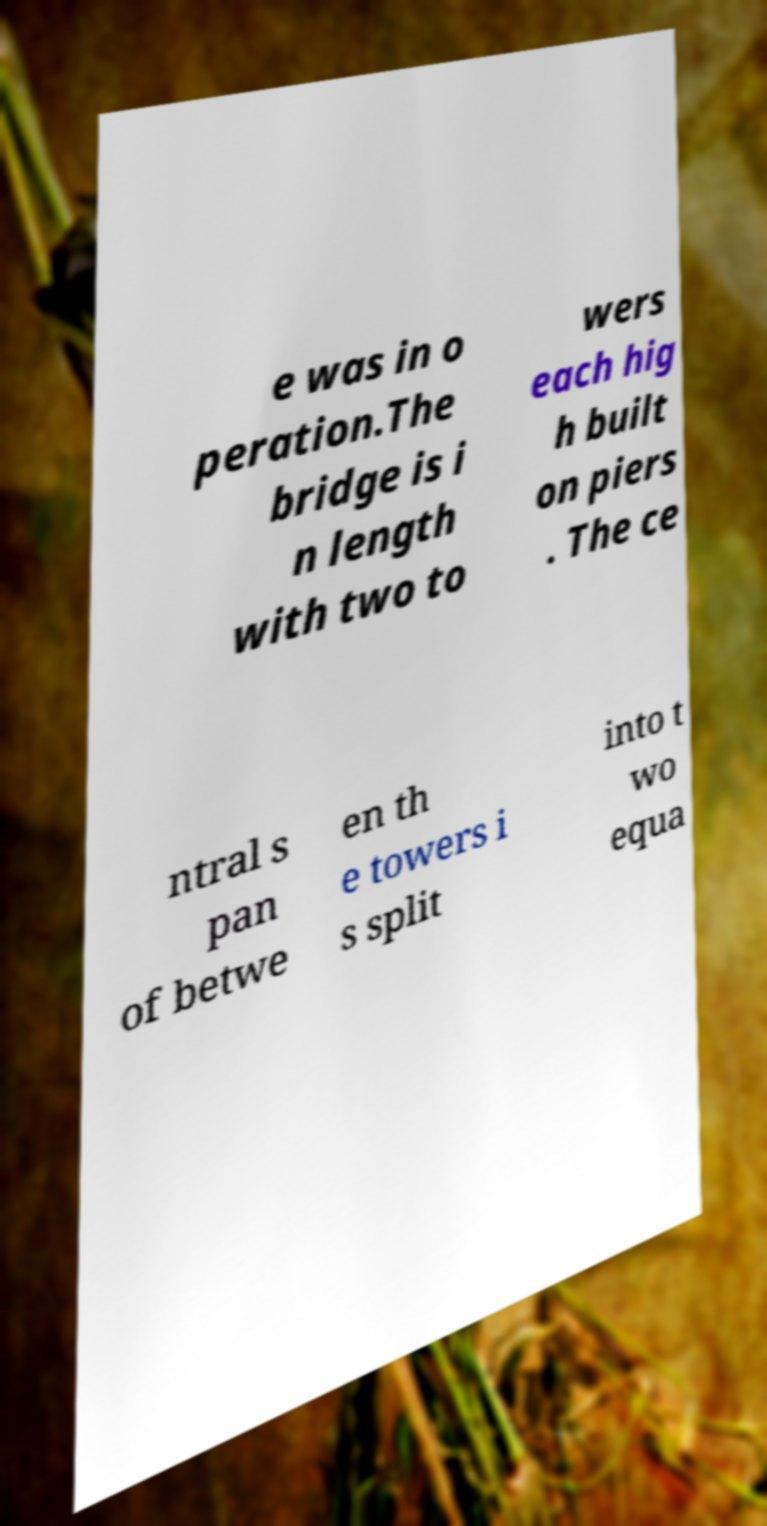I need the written content from this picture converted into text. Can you do that? e was in o peration.The bridge is i n length with two to wers each hig h built on piers . The ce ntral s pan of betwe en th e towers i s split into t wo equa 